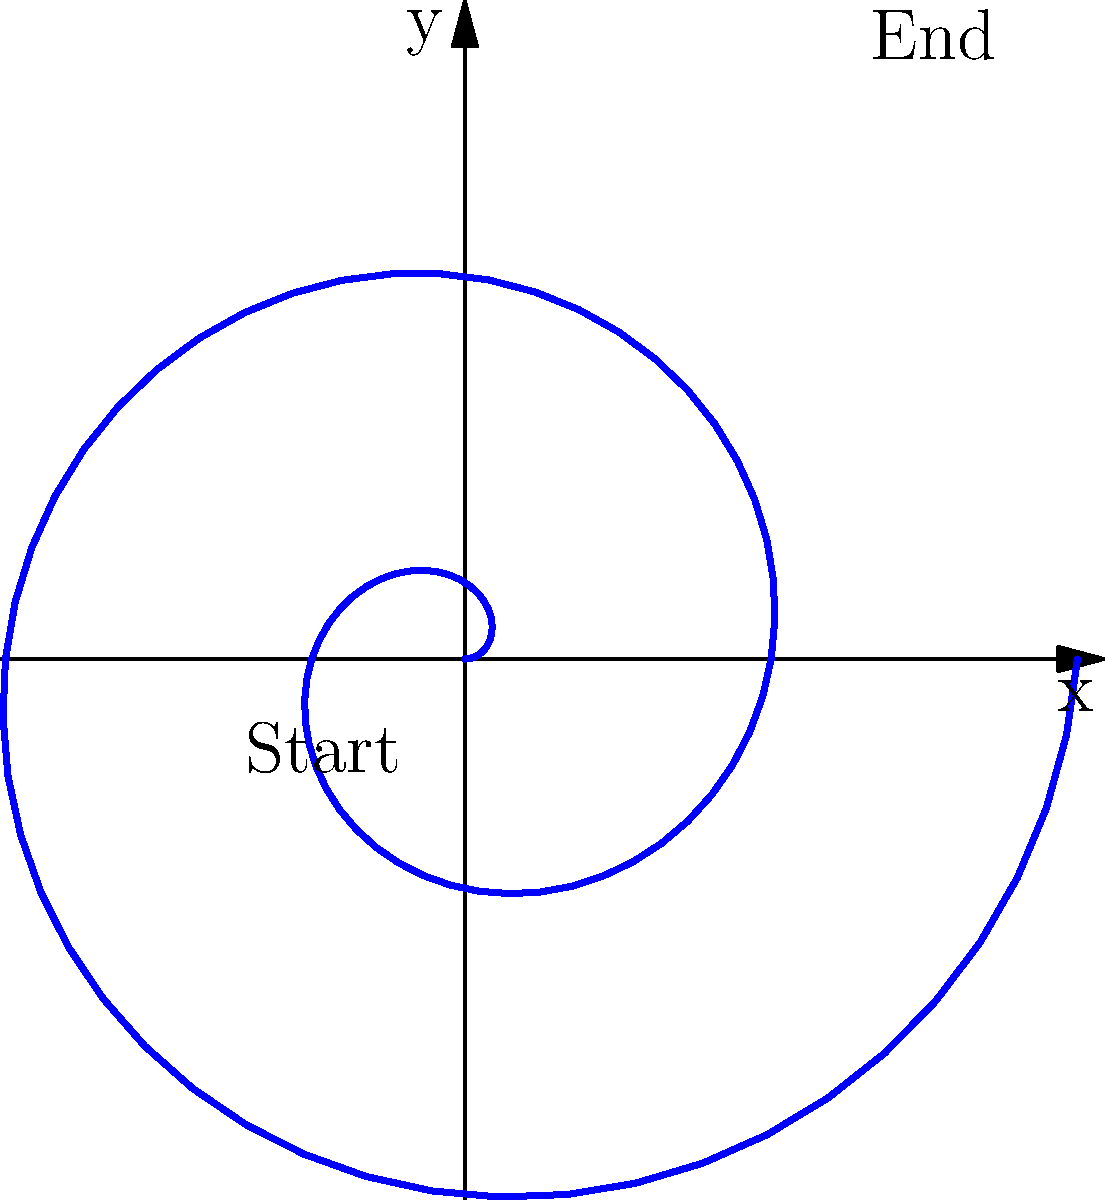In art therapy, you're asked to draw a spiral representing emotional growth using polar coordinates. The spiral starts at the origin and makes two complete revolutions. If the radius $r$ increases linearly with the angle $\theta$ according to the equation $r = 0.1\theta$, what is the maximum radius reached at the end of the spiral? To solve this problem, let's follow these steps:

1) We know that the spiral makes two complete revolutions. In polar coordinates, one complete revolution is $2\pi$ radians.

2) Therefore, two complete revolutions would be $4\pi$ radians.

3) The equation given for the spiral is $r = 0.1\theta$, where $r$ is the radius and $\theta$ is the angle in radians.

4) To find the maximum radius, we need to calculate $r$ when $\theta = 4\pi$:

   $r = 0.1 \cdot 4\pi$

5) Let's calculate this:
   $r = 0.1 \cdot 4 \cdot 3.14159...$
   $r \approx 1.25663...$

6) Rounding to two decimal places, we get 1.26.

Therefore, the maximum radius reached at the end of the spiral is approximately 1.26 units.
Answer: 1.26 units 